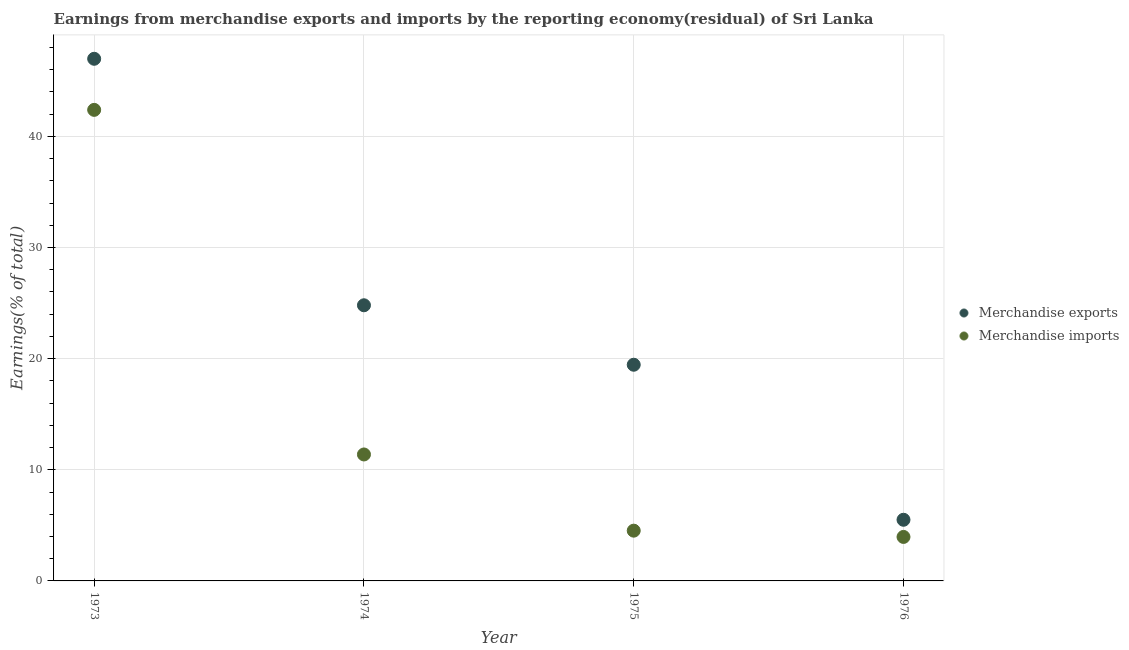Is the number of dotlines equal to the number of legend labels?
Keep it short and to the point. Yes. What is the earnings from merchandise exports in 1975?
Your answer should be compact. 19.45. Across all years, what is the maximum earnings from merchandise exports?
Offer a terse response. 46.98. Across all years, what is the minimum earnings from merchandise exports?
Ensure brevity in your answer.  5.5. In which year was the earnings from merchandise exports minimum?
Make the answer very short. 1976. What is the total earnings from merchandise imports in the graph?
Provide a succinct answer. 62.24. What is the difference between the earnings from merchandise exports in 1973 and that in 1974?
Your answer should be very brief. 22.18. What is the difference between the earnings from merchandise imports in 1974 and the earnings from merchandise exports in 1976?
Keep it short and to the point. 5.88. What is the average earnings from merchandise exports per year?
Give a very brief answer. 24.18. In the year 1974, what is the difference between the earnings from merchandise exports and earnings from merchandise imports?
Ensure brevity in your answer.  13.42. What is the ratio of the earnings from merchandise imports in 1974 to that in 1975?
Your answer should be compact. 2.52. Is the earnings from merchandise imports in 1973 less than that in 1976?
Offer a very short reply. No. Is the difference between the earnings from merchandise imports in 1974 and 1975 greater than the difference between the earnings from merchandise exports in 1974 and 1975?
Keep it short and to the point. Yes. What is the difference between the highest and the second highest earnings from merchandise exports?
Keep it short and to the point. 22.18. What is the difference between the highest and the lowest earnings from merchandise imports?
Your response must be concise. 38.43. In how many years, is the earnings from merchandise exports greater than the average earnings from merchandise exports taken over all years?
Give a very brief answer. 2. Is the sum of the earnings from merchandise exports in 1973 and 1976 greater than the maximum earnings from merchandise imports across all years?
Offer a terse response. Yes. Does the earnings from merchandise exports monotonically increase over the years?
Your response must be concise. No. Is the earnings from merchandise exports strictly greater than the earnings from merchandise imports over the years?
Ensure brevity in your answer.  Yes. Does the graph contain any zero values?
Provide a short and direct response. No. How are the legend labels stacked?
Your response must be concise. Vertical. What is the title of the graph?
Ensure brevity in your answer.  Earnings from merchandise exports and imports by the reporting economy(residual) of Sri Lanka. Does "Excluding technical cooperation" appear as one of the legend labels in the graph?
Offer a very short reply. No. What is the label or title of the X-axis?
Make the answer very short. Year. What is the label or title of the Y-axis?
Offer a terse response. Earnings(% of total). What is the Earnings(% of total) of Merchandise exports in 1973?
Provide a short and direct response. 46.98. What is the Earnings(% of total) of Merchandise imports in 1973?
Give a very brief answer. 42.39. What is the Earnings(% of total) of Merchandise exports in 1974?
Provide a short and direct response. 24.8. What is the Earnings(% of total) in Merchandise imports in 1974?
Offer a very short reply. 11.38. What is the Earnings(% of total) in Merchandise exports in 1975?
Offer a terse response. 19.45. What is the Earnings(% of total) in Merchandise imports in 1975?
Your answer should be very brief. 4.52. What is the Earnings(% of total) in Merchandise exports in 1976?
Your answer should be very brief. 5.5. What is the Earnings(% of total) in Merchandise imports in 1976?
Offer a terse response. 3.96. Across all years, what is the maximum Earnings(% of total) in Merchandise exports?
Your response must be concise. 46.98. Across all years, what is the maximum Earnings(% of total) of Merchandise imports?
Your response must be concise. 42.39. Across all years, what is the minimum Earnings(% of total) in Merchandise exports?
Your answer should be very brief. 5.5. Across all years, what is the minimum Earnings(% of total) in Merchandise imports?
Make the answer very short. 3.96. What is the total Earnings(% of total) of Merchandise exports in the graph?
Offer a very short reply. 96.74. What is the total Earnings(% of total) of Merchandise imports in the graph?
Offer a very short reply. 62.24. What is the difference between the Earnings(% of total) of Merchandise exports in 1973 and that in 1974?
Ensure brevity in your answer.  22.18. What is the difference between the Earnings(% of total) in Merchandise imports in 1973 and that in 1974?
Provide a succinct answer. 31.01. What is the difference between the Earnings(% of total) in Merchandise exports in 1973 and that in 1975?
Your answer should be compact. 27.53. What is the difference between the Earnings(% of total) of Merchandise imports in 1973 and that in 1975?
Your answer should be compact. 37.86. What is the difference between the Earnings(% of total) in Merchandise exports in 1973 and that in 1976?
Keep it short and to the point. 41.48. What is the difference between the Earnings(% of total) of Merchandise imports in 1973 and that in 1976?
Make the answer very short. 38.43. What is the difference between the Earnings(% of total) in Merchandise exports in 1974 and that in 1975?
Provide a succinct answer. 5.35. What is the difference between the Earnings(% of total) of Merchandise imports in 1974 and that in 1975?
Provide a short and direct response. 6.86. What is the difference between the Earnings(% of total) in Merchandise exports in 1974 and that in 1976?
Make the answer very short. 19.3. What is the difference between the Earnings(% of total) of Merchandise imports in 1974 and that in 1976?
Your response must be concise. 7.42. What is the difference between the Earnings(% of total) of Merchandise exports in 1975 and that in 1976?
Your answer should be compact. 13.95. What is the difference between the Earnings(% of total) in Merchandise imports in 1975 and that in 1976?
Offer a very short reply. 0.56. What is the difference between the Earnings(% of total) of Merchandise exports in 1973 and the Earnings(% of total) of Merchandise imports in 1974?
Your answer should be compact. 35.6. What is the difference between the Earnings(% of total) in Merchandise exports in 1973 and the Earnings(% of total) in Merchandise imports in 1975?
Give a very brief answer. 42.46. What is the difference between the Earnings(% of total) in Merchandise exports in 1973 and the Earnings(% of total) in Merchandise imports in 1976?
Your answer should be compact. 43.02. What is the difference between the Earnings(% of total) in Merchandise exports in 1974 and the Earnings(% of total) in Merchandise imports in 1975?
Give a very brief answer. 20.28. What is the difference between the Earnings(% of total) in Merchandise exports in 1974 and the Earnings(% of total) in Merchandise imports in 1976?
Give a very brief answer. 20.84. What is the difference between the Earnings(% of total) in Merchandise exports in 1975 and the Earnings(% of total) in Merchandise imports in 1976?
Provide a succinct answer. 15.49. What is the average Earnings(% of total) in Merchandise exports per year?
Offer a very short reply. 24.18. What is the average Earnings(% of total) in Merchandise imports per year?
Your answer should be compact. 15.56. In the year 1973, what is the difference between the Earnings(% of total) in Merchandise exports and Earnings(% of total) in Merchandise imports?
Your answer should be very brief. 4.6. In the year 1974, what is the difference between the Earnings(% of total) of Merchandise exports and Earnings(% of total) of Merchandise imports?
Make the answer very short. 13.42. In the year 1975, what is the difference between the Earnings(% of total) in Merchandise exports and Earnings(% of total) in Merchandise imports?
Provide a succinct answer. 14.93. In the year 1976, what is the difference between the Earnings(% of total) of Merchandise exports and Earnings(% of total) of Merchandise imports?
Make the answer very short. 1.54. What is the ratio of the Earnings(% of total) of Merchandise exports in 1973 to that in 1974?
Your answer should be compact. 1.89. What is the ratio of the Earnings(% of total) in Merchandise imports in 1973 to that in 1974?
Offer a very short reply. 3.73. What is the ratio of the Earnings(% of total) in Merchandise exports in 1973 to that in 1975?
Your response must be concise. 2.42. What is the ratio of the Earnings(% of total) of Merchandise imports in 1973 to that in 1975?
Your answer should be compact. 9.37. What is the ratio of the Earnings(% of total) in Merchandise exports in 1973 to that in 1976?
Provide a succinct answer. 8.54. What is the ratio of the Earnings(% of total) in Merchandise imports in 1973 to that in 1976?
Ensure brevity in your answer.  10.71. What is the ratio of the Earnings(% of total) of Merchandise exports in 1974 to that in 1975?
Make the answer very short. 1.28. What is the ratio of the Earnings(% of total) in Merchandise imports in 1974 to that in 1975?
Make the answer very short. 2.52. What is the ratio of the Earnings(% of total) of Merchandise exports in 1974 to that in 1976?
Offer a terse response. 4.51. What is the ratio of the Earnings(% of total) of Merchandise imports in 1974 to that in 1976?
Offer a terse response. 2.87. What is the ratio of the Earnings(% of total) in Merchandise exports in 1975 to that in 1976?
Your answer should be very brief. 3.53. What is the ratio of the Earnings(% of total) in Merchandise imports in 1975 to that in 1976?
Your answer should be compact. 1.14. What is the difference between the highest and the second highest Earnings(% of total) in Merchandise exports?
Give a very brief answer. 22.18. What is the difference between the highest and the second highest Earnings(% of total) of Merchandise imports?
Give a very brief answer. 31.01. What is the difference between the highest and the lowest Earnings(% of total) in Merchandise exports?
Give a very brief answer. 41.48. What is the difference between the highest and the lowest Earnings(% of total) of Merchandise imports?
Ensure brevity in your answer.  38.43. 